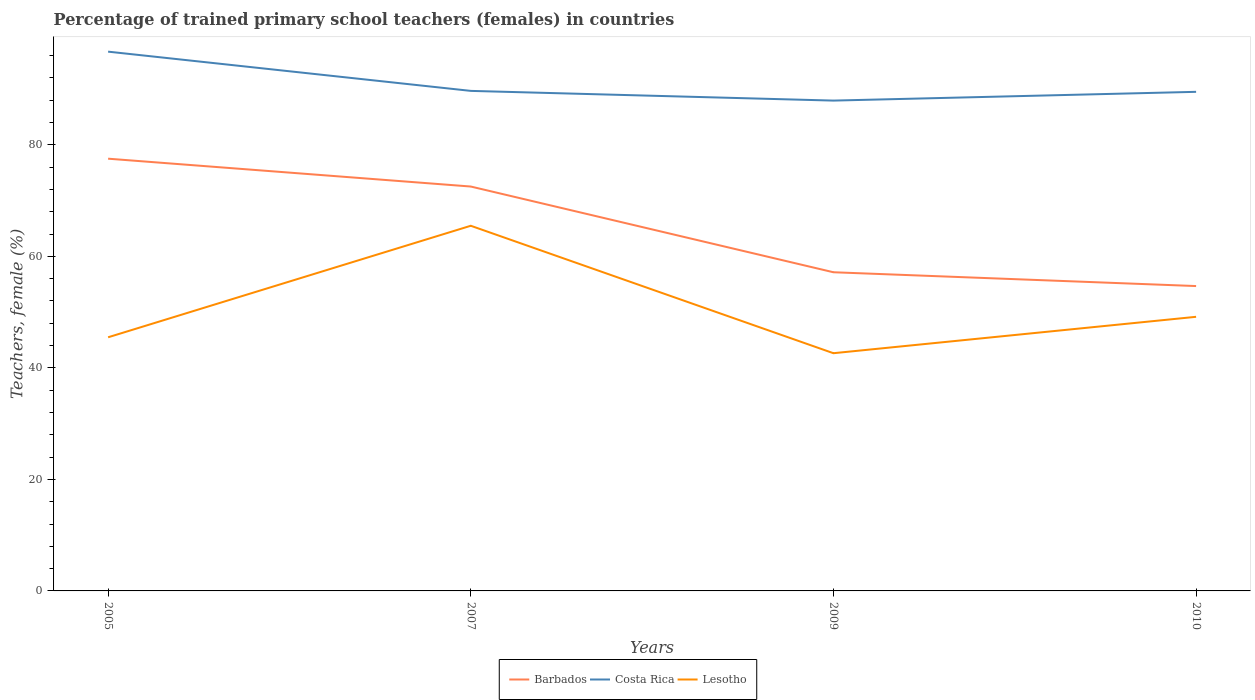How many different coloured lines are there?
Your response must be concise. 3. Does the line corresponding to Costa Rica intersect with the line corresponding to Barbados?
Offer a terse response. No. Is the number of lines equal to the number of legend labels?
Offer a very short reply. Yes. Across all years, what is the maximum percentage of trained primary school teachers (females) in Lesotho?
Provide a succinct answer. 42.63. In which year was the percentage of trained primary school teachers (females) in Costa Rica maximum?
Keep it short and to the point. 2009. What is the total percentage of trained primary school teachers (females) in Barbados in the graph?
Keep it short and to the point. 2.48. What is the difference between the highest and the second highest percentage of trained primary school teachers (females) in Barbados?
Make the answer very short. 22.84. Is the percentage of trained primary school teachers (females) in Lesotho strictly greater than the percentage of trained primary school teachers (females) in Costa Rica over the years?
Offer a very short reply. Yes. How many years are there in the graph?
Offer a terse response. 4. How many legend labels are there?
Make the answer very short. 3. What is the title of the graph?
Give a very brief answer. Percentage of trained primary school teachers (females) in countries. Does "Finland" appear as one of the legend labels in the graph?
Your response must be concise. No. What is the label or title of the Y-axis?
Make the answer very short. Teachers, female (%). What is the Teachers, female (%) of Barbados in 2005?
Your answer should be compact. 77.51. What is the Teachers, female (%) in Costa Rica in 2005?
Give a very brief answer. 96.7. What is the Teachers, female (%) in Lesotho in 2005?
Offer a very short reply. 45.48. What is the Teachers, female (%) in Barbados in 2007?
Give a very brief answer. 72.51. What is the Teachers, female (%) in Costa Rica in 2007?
Your answer should be very brief. 89.67. What is the Teachers, female (%) of Lesotho in 2007?
Provide a short and direct response. 65.48. What is the Teachers, female (%) of Barbados in 2009?
Give a very brief answer. 57.14. What is the Teachers, female (%) of Costa Rica in 2009?
Make the answer very short. 87.93. What is the Teachers, female (%) in Lesotho in 2009?
Your answer should be compact. 42.63. What is the Teachers, female (%) in Barbados in 2010?
Keep it short and to the point. 54.67. What is the Teachers, female (%) of Costa Rica in 2010?
Ensure brevity in your answer.  89.5. What is the Teachers, female (%) of Lesotho in 2010?
Your answer should be very brief. 49.15. Across all years, what is the maximum Teachers, female (%) of Barbados?
Offer a terse response. 77.51. Across all years, what is the maximum Teachers, female (%) in Costa Rica?
Your response must be concise. 96.7. Across all years, what is the maximum Teachers, female (%) in Lesotho?
Provide a succinct answer. 65.48. Across all years, what is the minimum Teachers, female (%) in Barbados?
Offer a terse response. 54.67. Across all years, what is the minimum Teachers, female (%) of Costa Rica?
Offer a very short reply. 87.93. Across all years, what is the minimum Teachers, female (%) in Lesotho?
Your answer should be very brief. 42.63. What is the total Teachers, female (%) in Barbados in the graph?
Offer a very short reply. 261.83. What is the total Teachers, female (%) of Costa Rica in the graph?
Your answer should be very brief. 363.79. What is the total Teachers, female (%) in Lesotho in the graph?
Your response must be concise. 202.74. What is the difference between the Teachers, female (%) in Barbados in 2005 and that in 2007?
Ensure brevity in your answer.  4.99. What is the difference between the Teachers, female (%) in Costa Rica in 2005 and that in 2007?
Your answer should be very brief. 7.04. What is the difference between the Teachers, female (%) in Lesotho in 2005 and that in 2007?
Keep it short and to the point. -20. What is the difference between the Teachers, female (%) in Barbados in 2005 and that in 2009?
Provide a succinct answer. 20.36. What is the difference between the Teachers, female (%) in Costa Rica in 2005 and that in 2009?
Your response must be concise. 8.78. What is the difference between the Teachers, female (%) of Lesotho in 2005 and that in 2009?
Provide a short and direct response. 2.86. What is the difference between the Teachers, female (%) of Barbados in 2005 and that in 2010?
Make the answer very short. 22.84. What is the difference between the Teachers, female (%) of Costa Rica in 2005 and that in 2010?
Keep it short and to the point. 7.2. What is the difference between the Teachers, female (%) in Lesotho in 2005 and that in 2010?
Ensure brevity in your answer.  -3.67. What is the difference between the Teachers, female (%) in Barbados in 2007 and that in 2009?
Your answer should be compact. 15.37. What is the difference between the Teachers, female (%) in Costa Rica in 2007 and that in 2009?
Ensure brevity in your answer.  1.74. What is the difference between the Teachers, female (%) of Lesotho in 2007 and that in 2009?
Your answer should be very brief. 22.85. What is the difference between the Teachers, female (%) in Barbados in 2007 and that in 2010?
Make the answer very short. 17.85. What is the difference between the Teachers, female (%) in Costa Rica in 2007 and that in 2010?
Make the answer very short. 0.17. What is the difference between the Teachers, female (%) of Lesotho in 2007 and that in 2010?
Ensure brevity in your answer.  16.33. What is the difference between the Teachers, female (%) in Barbados in 2009 and that in 2010?
Offer a terse response. 2.48. What is the difference between the Teachers, female (%) in Costa Rica in 2009 and that in 2010?
Offer a terse response. -1.57. What is the difference between the Teachers, female (%) of Lesotho in 2009 and that in 2010?
Keep it short and to the point. -6.53. What is the difference between the Teachers, female (%) in Barbados in 2005 and the Teachers, female (%) in Costa Rica in 2007?
Provide a short and direct response. -12.16. What is the difference between the Teachers, female (%) of Barbados in 2005 and the Teachers, female (%) of Lesotho in 2007?
Provide a succinct answer. 12.03. What is the difference between the Teachers, female (%) in Costa Rica in 2005 and the Teachers, female (%) in Lesotho in 2007?
Your answer should be compact. 31.22. What is the difference between the Teachers, female (%) in Barbados in 2005 and the Teachers, female (%) in Costa Rica in 2009?
Ensure brevity in your answer.  -10.42. What is the difference between the Teachers, female (%) in Barbados in 2005 and the Teachers, female (%) in Lesotho in 2009?
Ensure brevity in your answer.  34.88. What is the difference between the Teachers, female (%) of Costa Rica in 2005 and the Teachers, female (%) of Lesotho in 2009?
Your answer should be very brief. 54.07. What is the difference between the Teachers, female (%) in Barbados in 2005 and the Teachers, female (%) in Costa Rica in 2010?
Provide a succinct answer. -11.99. What is the difference between the Teachers, female (%) in Barbados in 2005 and the Teachers, female (%) in Lesotho in 2010?
Give a very brief answer. 28.35. What is the difference between the Teachers, female (%) in Costa Rica in 2005 and the Teachers, female (%) in Lesotho in 2010?
Your answer should be compact. 47.55. What is the difference between the Teachers, female (%) in Barbados in 2007 and the Teachers, female (%) in Costa Rica in 2009?
Offer a very short reply. -15.41. What is the difference between the Teachers, female (%) of Barbados in 2007 and the Teachers, female (%) of Lesotho in 2009?
Provide a succinct answer. 29.89. What is the difference between the Teachers, female (%) in Costa Rica in 2007 and the Teachers, female (%) in Lesotho in 2009?
Provide a short and direct response. 47.04. What is the difference between the Teachers, female (%) in Barbados in 2007 and the Teachers, female (%) in Costa Rica in 2010?
Your answer should be compact. -16.98. What is the difference between the Teachers, female (%) of Barbados in 2007 and the Teachers, female (%) of Lesotho in 2010?
Keep it short and to the point. 23.36. What is the difference between the Teachers, female (%) of Costa Rica in 2007 and the Teachers, female (%) of Lesotho in 2010?
Offer a very short reply. 40.51. What is the difference between the Teachers, female (%) of Barbados in 2009 and the Teachers, female (%) of Costa Rica in 2010?
Your answer should be compact. -32.36. What is the difference between the Teachers, female (%) in Barbados in 2009 and the Teachers, female (%) in Lesotho in 2010?
Your answer should be very brief. 7.99. What is the difference between the Teachers, female (%) in Costa Rica in 2009 and the Teachers, female (%) in Lesotho in 2010?
Your answer should be compact. 38.77. What is the average Teachers, female (%) of Barbados per year?
Offer a terse response. 65.46. What is the average Teachers, female (%) of Costa Rica per year?
Make the answer very short. 90.95. What is the average Teachers, female (%) in Lesotho per year?
Give a very brief answer. 50.69. In the year 2005, what is the difference between the Teachers, female (%) of Barbados and Teachers, female (%) of Costa Rica?
Keep it short and to the point. -19.19. In the year 2005, what is the difference between the Teachers, female (%) in Barbados and Teachers, female (%) in Lesotho?
Offer a terse response. 32.02. In the year 2005, what is the difference between the Teachers, female (%) of Costa Rica and Teachers, female (%) of Lesotho?
Keep it short and to the point. 51.22. In the year 2007, what is the difference between the Teachers, female (%) of Barbados and Teachers, female (%) of Costa Rica?
Your answer should be compact. -17.15. In the year 2007, what is the difference between the Teachers, female (%) in Barbados and Teachers, female (%) in Lesotho?
Provide a short and direct response. 7.04. In the year 2007, what is the difference between the Teachers, female (%) of Costa Rica and Teachers, female (%) of Lesotho?
Your response must be concise. 24.19. In the year 2009, what is the difference between the Teachers, female (%) in Barbados and Teachers, female (%) in Costa Rica?
Provide a succinct answer. -30.78. In the year 2009, what is the difference between the Teachers, female (%) in Barbados and Teachers, female (%) in Lesotho?
Provide a succinct answer. 14.52. In the year 2009, what is the difference between the Teachers, female (%) in Costa Rica and Teachers, female (%) in Lesotho?
Provide a short and direct response. 45.3. In the year 2010, what is the difference between the Teachers, female (%) in Barbados and Teachers, female (%) in Costa Rica?
Provide a short and direct response. -34.83. In the year 2010, what is the difference between the Teachers, female (%) in Barbados and Teachers, female (%) in Lesotho?
Ensure brevity in your answer.  5.51. In the year 2010, what is the difference between the Teachers, female (%) of Costa Rica and Teachers, female (%) of Lesotho?
Make the answer very short. 40.34. What is the ratio of the Teachers, female (%) of Barbados in 2005 to that in 2007?
Ensure brevity in your answer.  1.07. What is the ratio of the Teachers, female (%) in Costa Rica in 2005 to that in 2007?
Your answer should be very brief. 1.08. What is the ratio of the Teachers, female (%) in Lesotho in 2005 to that in 2007?
Ensure brevity in your answer.  0.69. What is the ratio of the Teachers, female (%) of Barbados in 2005 to that in 2009?
Make the answer very short. 1.36. What is the ratio of the Teachers, female (%) in Costa Rica in 2005 to that in 2009?
Make the answer very short. 1.1. What is the ratio of the Teachers, female (%) in Lesotho in 2005 to that in 2009?
Give a very brief answer. 1.07. What is the ratio of the Teachers, female (%) in Barbados in 2005 to that in 2010?
Make the answer very short. 1.42. What is the ratio of the Teachers, female (%) of Costa Rica in 2005 to that in 2010?
Offer a terse response. 1.08. What is the ratio of the Teachers, female (%) of Lesotho in 2005 to that in 2010?
Your answer should be very brief. 0.93. What is the ratio of the Teachers, female (%) of Barbados in 2007 to that in 2009?
Offer a terse response. 1.27. What is the ratio of the Teachers, female (%) of Costa Rica in 2007 to that in 2009?
Make the answer very short. 1.02. What is the ratio of the Teachers, female (%) in Lesotho in 2007 to that in 2009?
Provide a succinct answer. 1.54. What is the ratio of the Teachers, female (%) in Barbados in 2007 to that in 2010?
Your answer should be very brief. 1.33. What is the ratio of the Teachers, female (%) of Lesotho in 2007 to that in 2010?
Offer a very short reply. 1.33. What is the ratio of the Teachers, female (%) in Barbados in 2009 to that in 2010?
Offer a very short reply. 1.05. What is the ratio of the Teachers, female (%) of Costa Rica in 2009 to that in 2010?
Provide a short and direct response. 0.98. What is the ratio of the Teachers, female (%) of Lesotho in 2009 to that in 2010?
Provide a succinct answer. 0.87. What is the difference between the highest and the second highest Teachers, female (%) of Barbados?
Offer a terse response. 4.99. What is the difference between the highest and the second highest Teachers, female (%) in Costa Rica?
Offer a terse response. 7.04. What is the difference between the highest and the second highest Teachers, female (%) of Lesotho?
Ensure brevity in your answer.  16.33. What is the difference between the highest and the lowest Teachers, female (%) of Barbados?
Your response must be concise. 22.84. What is the difference between the highest and the lowest Teachers, female (%) in Costa Rica?
Provide a succinct answer. 8.78. What is the difference between the highest and the lowest Teachers, female (%) in Lesotho?
Offer a very short reply. 22.85. 